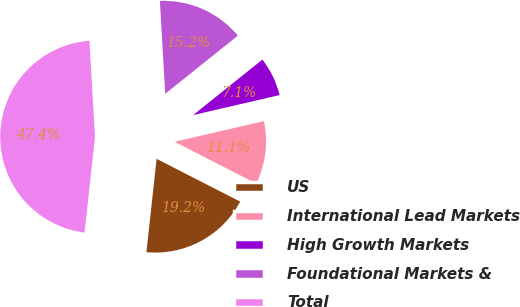<chart> <loc_0><loc_0><loc_500><loc_500><pie_chart><fcel>US<fcel>International Lead Markets<fcel>High Growth Markets<fcel>Foundational Markets &<fcel>Total<nl><fcel>19.2%<fcel>11.15%<fcel>7.13%<fcel>15.17%<fcel>47.36%<nl></chart> 